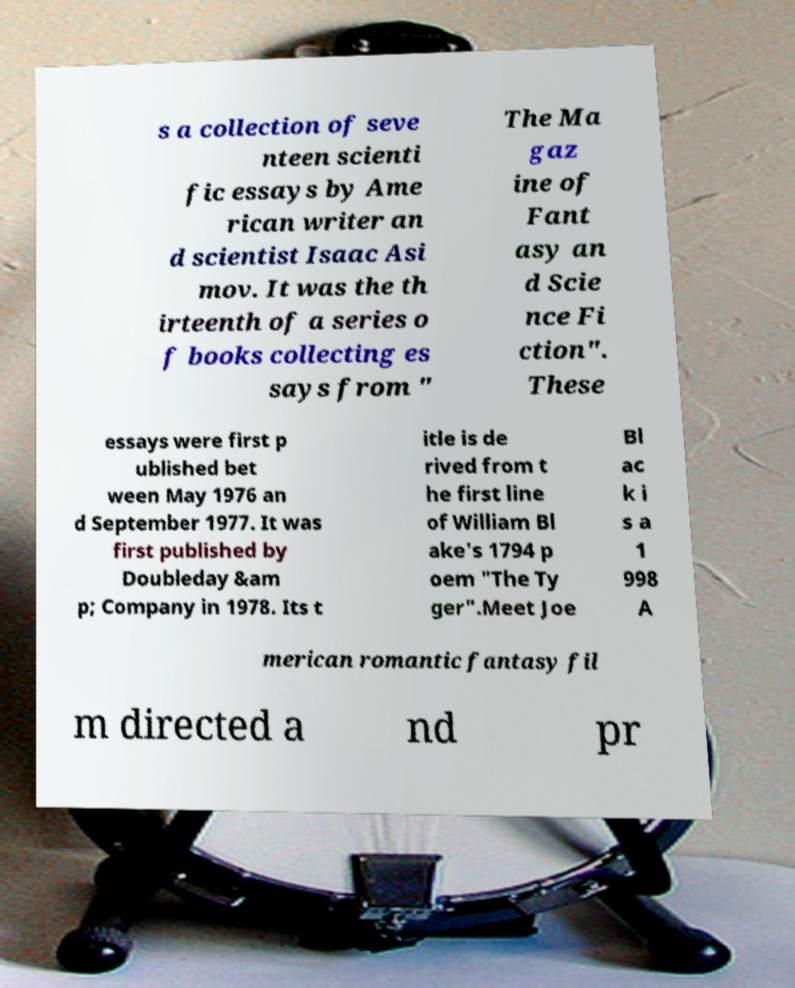There's text embedded in this image that I need extracted. Can you transcribe it verbatim? s a collection of seve nteen scienti fic essays by Ame rican writer an d scientist Isaac Asi mov. It was the th irteenth of a series o f books collecting es says from " The Ma gaz ine of Fant asy an d Scie nce Fi ction". These essays were first p ublished bet ween May 1976 an d September 1977. It was first published by Doubleday &am p; Company in 1978. Its t itle is de rived from t he first line of William Bl ake's 1794 p oem "The Ty ger".Meet Joe Bl ac k i s a 1 998 A merican romantic fantasy fil m directed a nd pr 